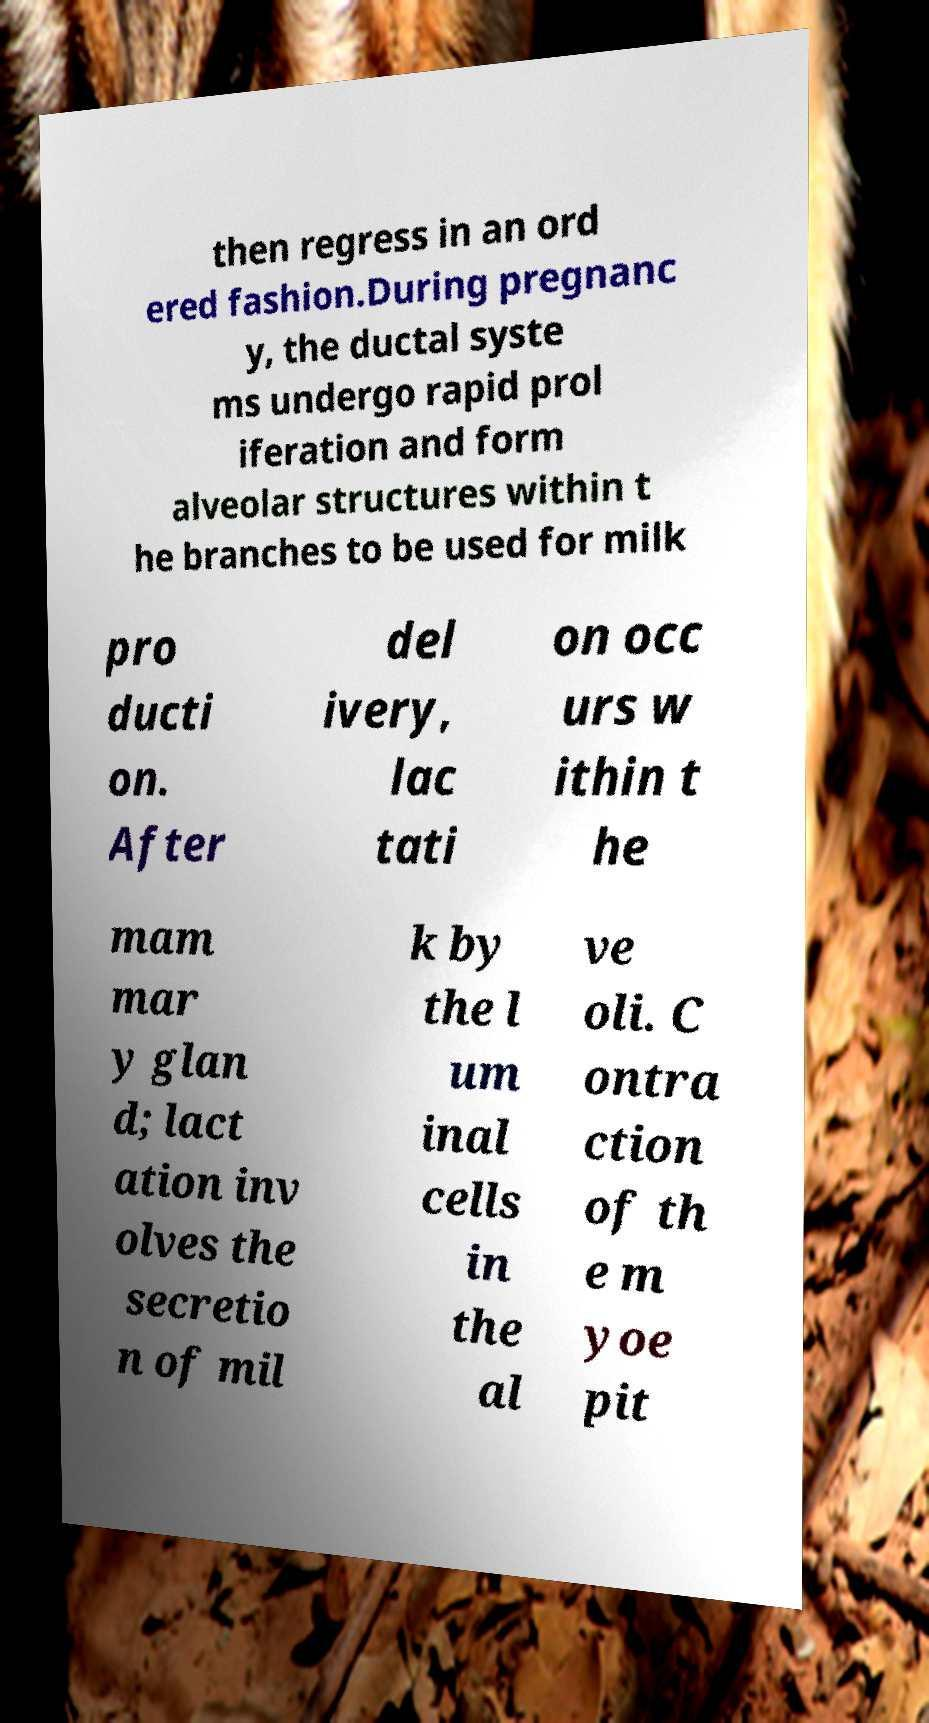I need the written content from this picture converted into text. Can you do that? then regress in an ord ered fashion.During pregnanc y, the ductal syste ms undergo rapid prol iferation and form alveolar structures within t he branches to be used for milk pro ducti on. After del ivery, lac tati on occ urs w ithin t he mam mar y glan d; lact ation inv olves the secretio n of mil k by the l um inal cells in the al ve oli. C ontra ction of th e m yoe pit 